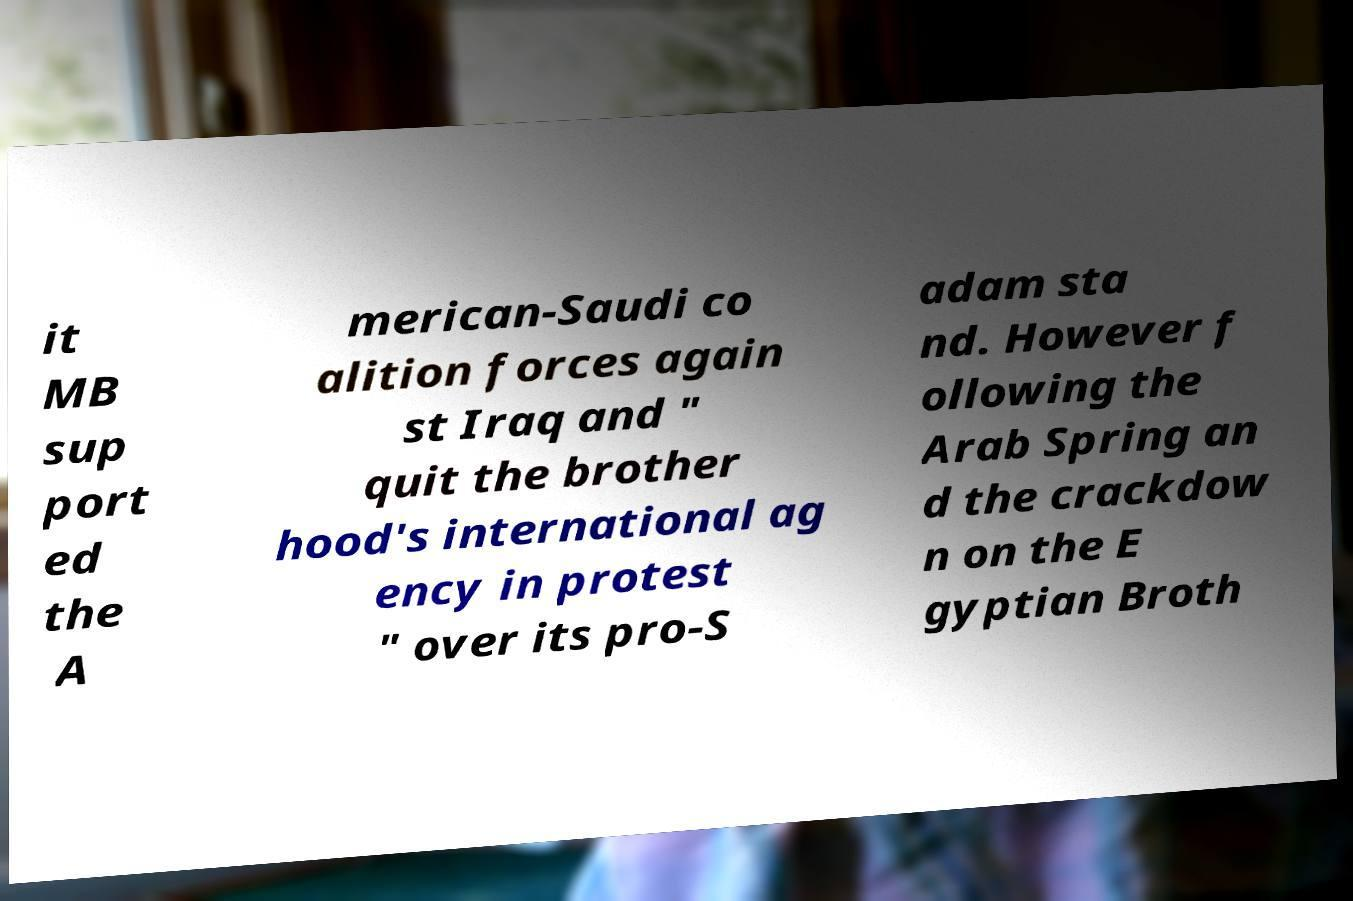Could you assist in decoding the text presented in this image and type it out clearly? it MB sup port ed the A merican-Saudi co alition forces again st Iraq and " quit the brother hood's international ag ency in protest " over its pro-S adam sta nd. However f ollowing the Arab Spring an d the crackdow n on the E gyptian Broth 